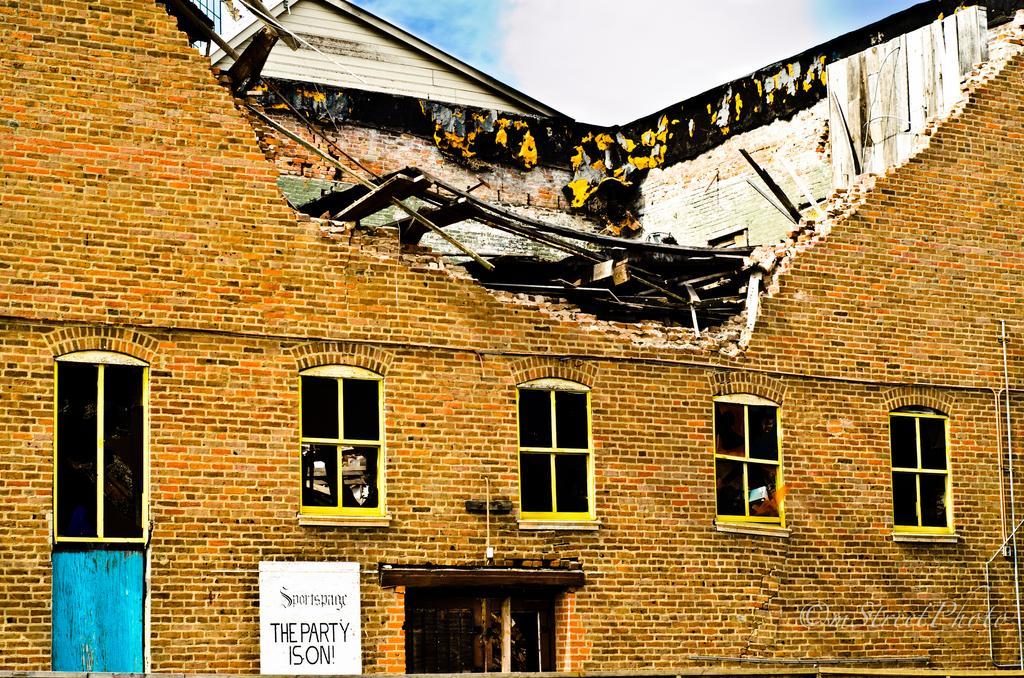Can you describe this image briefly? In this picture I can see a collapsed building, there is a name board, and in the background there is sky and a watermark on the image. 